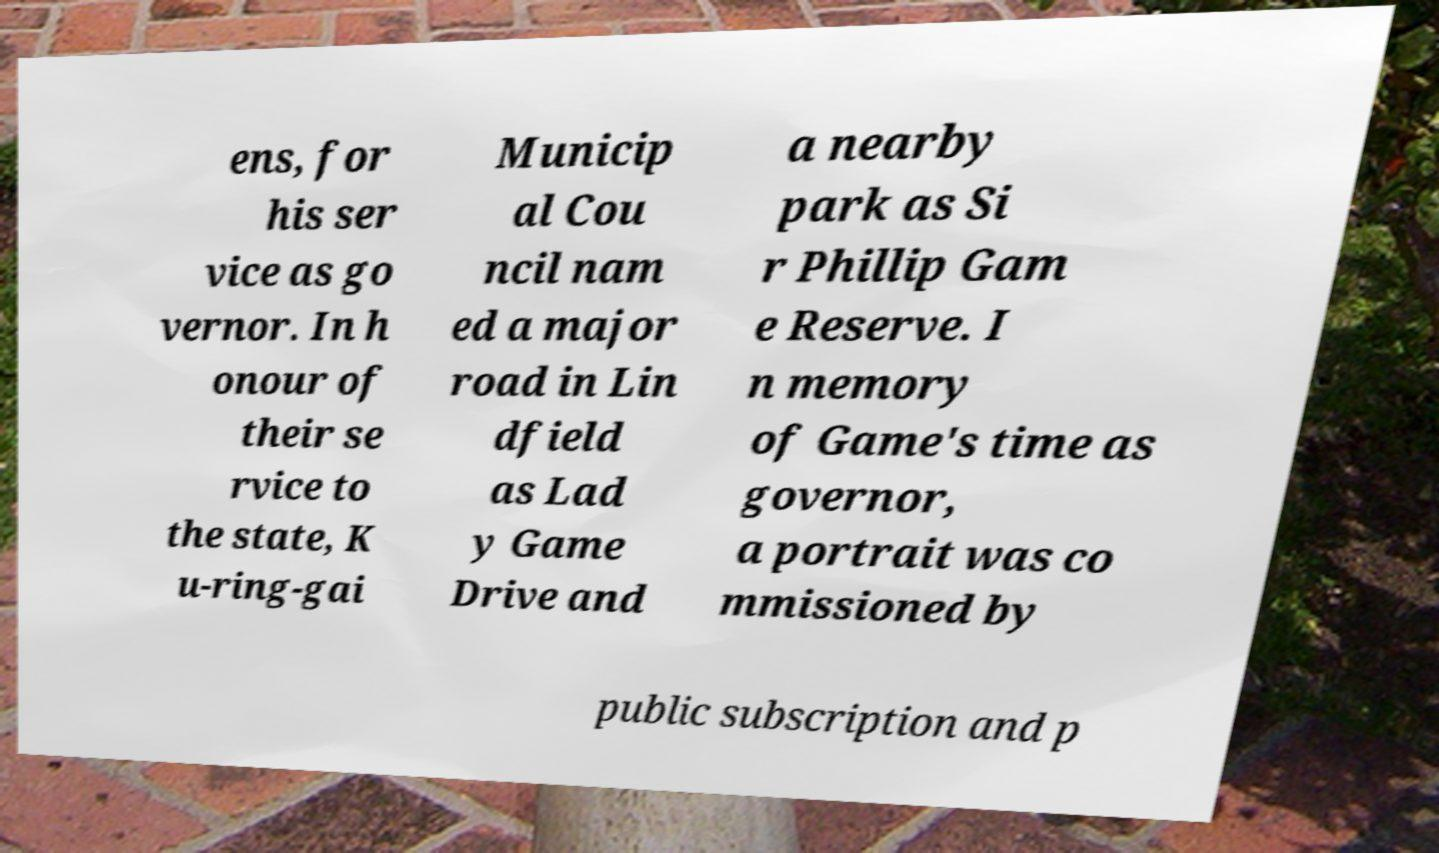For documentation purposes, I need the text within this image transcribed. Could you provide that? ens, for his ser vice as go vernor. In h onour of their se rvice to the state, K u-ring-gai Municip al Cou ncil nam ed a major road in Lin dfield as Lad y Game Drive and a nearby park as Si r Phillip Gam e Reserve. I n memory of Game's time as governor, a portrait was co mmissioned by public subscription and p 